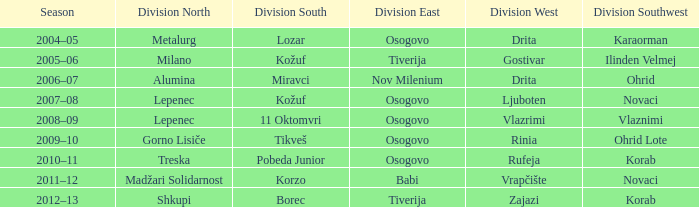Can you parse all the data within this table? {'header': ['Season', 'Division North', 'Division South', 'Division East', 'Division West', 'Division Southwest'], 'rows': [['2004–05', 'Metalurg', 'Lozar', 'Osogovo', 'Drita', 'Karaorman'], ['2005–06', 'Milano', 'Kožuf', 'Tiverija', 'Gostivar', 'Ilinden Velmej'], ['2006–07', 'Alumina', 'Miravci', 'Nov Milenium', 'Drita', 'Ohrid'], ['2007–08', 'Lepenec', 'Kožuf', 'Osogovo', 'Ljuboten', 'Novaci'], ['2008–09', 'Lepenec', '11 Oktomvri', 'Osogovo', 'Vlazrimi', 'Vlaznimi'], ['2009–10', 'Gorno Lisiče', 'Tikveš', 'Osogovo', 'Rinia', 'Ohrid Lote'], ['2010–11', 'Treska', 'Pobeda Junior', 'Osogovo', 'Rufeja', 'Korab'], ['2011–12', 'Madžari Solidarnost', 'Korzo', 'Babi', 'Vrapčište', 'Novaci'], ['2012–13', 'Shkupi', 'Borec', 'Tiverija', 'Zajazi', 'Korab']]} When lepenec secured the victory in division north and 11 oktomvri triumphed in division south, who was the champion of division southwest? Vlaznimi. 